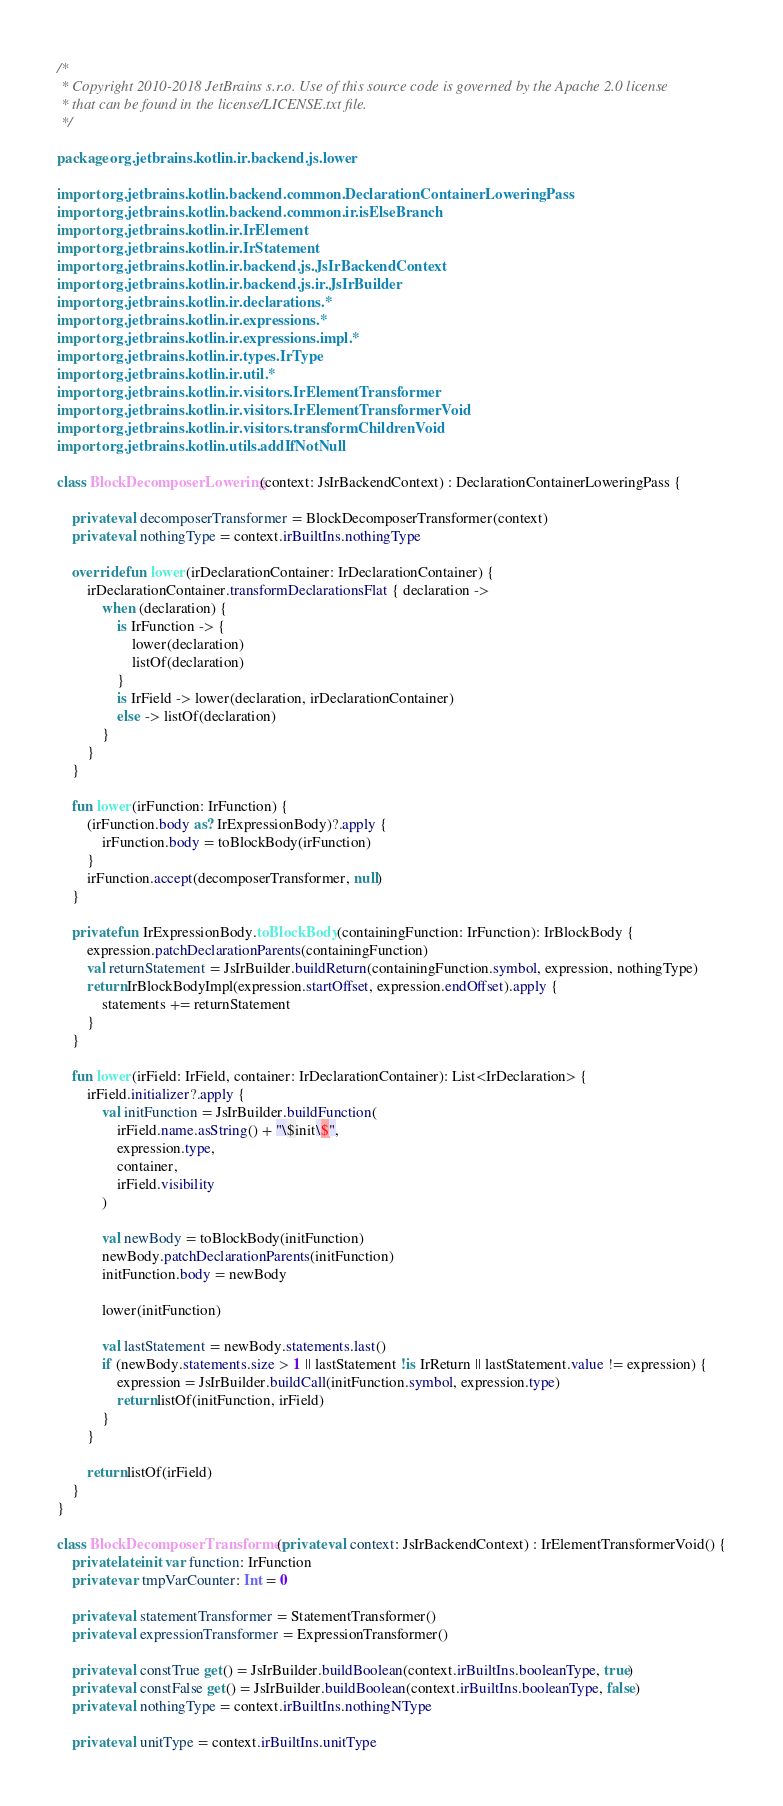Convert code to text. <code><loc_0><loc_0><loc_500><loc_500><_Kotlin_>/*
 * Copyright 2010-2018 JetBrains s.r.o. Use of this source code is governed by the Apache 2.0 license
 * that can be found in the license/LICENSE.txt file.
 */

package org.jetbrains.kotlin.ir.backend.js.lower

import org.jetbrains.kotlin.backend.common.DeclarationContainerLoweringPass
import org.jetbrains.kotlin.backend.common.ir.isElseBranch
import org.jetbrains.kotlin.ir.IrElement
import org.jetbrains.kotlin.ir.IrStatement
import org.jetbrains.kotlin.ir.backend.js.JsIrBackendContext
import org.jetbrains.kotlin.ir.backend.js.ir.JsIrBuilder
import org.jetbrains.kotlin.ir.declarations.*
import org.jetbrains.kotlin.ir.expressions.*
import org.jetbrains.kotlin.ir.expressions.impl.*
import org.jetbrains.kotlin.ir.types.IrType
import org.jetbrains.kotlin.ir.util.*
import org.jetbrains.kotlin.ir.visitors.IrElementTransformer
import org.jetbrains.kotlin.ir.visitors.IrElementTransformerVoid
import org.jetbrains.kotlin.ir.visitors.transformChildrenVoid
import org.jetbrains.kotlin.utils.addIfNotNull

class BlockDecomposerLowering(context: JsIrBackendContext) : DeclarationContainerLoweringPass {

    private val decomposerTransformer = BlockDecomposerTransformer(context)
    private val nothingType = context.irBuiltIns.nothingType

    override fun lower(irDeclarationContainer: IrDeclarationContainer) {
        irDeclarationContainer.transformDeclarationsFlat { declaration ->
            when (declaration) {
                is IrFunction -> {
                    lower(declaration)
                    listOf(declaration)
                }
                is IrField -> lower(declaration, irDeclarationContainer)
                else -> listOf(declaration)
            }
        }
    }

    fun lower(irFunction: IrFunction) {
        (irFunction.body as? IrExpressionBody)?.apply {
            irFunction.body = toBlockBody(irFunction)
        }
        irFunction.accept(decomposerTransformer, null)
    }

    private fun IrExpressionBody.toBlockBody(containingFunction: IrFunction): IrBlockBody {
        expression.patchDeclarationParents(containingFunction)
        val returnStatement = JsIrBuilder.buildReturn(containingFunction.symbol, expression, nothingType)
        return IrBlockBodyImpl(expression.startOffset, expression.endOffset).apply {
            statements += returnStatement
        }
    }

    fun lower(irField: IrField, container: IrDeclarationContainer): List<IrDeclaration> {
        irField.initializer?.apply {
            val initFunction = JsIrBuilder.buildFunction(
                irField.name.asString() + "\$init\$",
                expression.type,
                container,
                irField.visibility
            )

            val newBody = toBlockBody(initFunction)
            newBody.patchDeclarationParents(initFunction)
            initFunction.body = newBody

            lower(initFunction)

            val lastStatement = newBody.statements.last()
            if (newBody.statements.size > 1 || lastStatement !is IrReturn || lastStatement.value != expression) {
                expression = JsIrBuilder.buildCall(initFunction.symbol, expression.type)
                return listOf(initFunction, irField)
            }
        }

        return listOf(irField)
    }
}

class BlockDecomposerTransformer(private val context: JsIrBackendContext) : IrElementTransformerVoid() {
    private lateinit var function: IrFunction
    private var tmpVarCounter: Int = 0

    private val statementTransformer = StatementTransformer()
    private val expressionTransformer = ExpressionTransformer()

    private val constTrue get() = JsIrBuilder.buildBoolean(context.irBuiltIns.booleanType, true)
    private val constFalse get() = JsIrBuilder.buildBoolean(context.irBuiltIns.booleanType, false)
    private val nothingType = context.irBuiltIns.nothingNType

    private val unitType = context.irBuiltIns.unitType</code> 